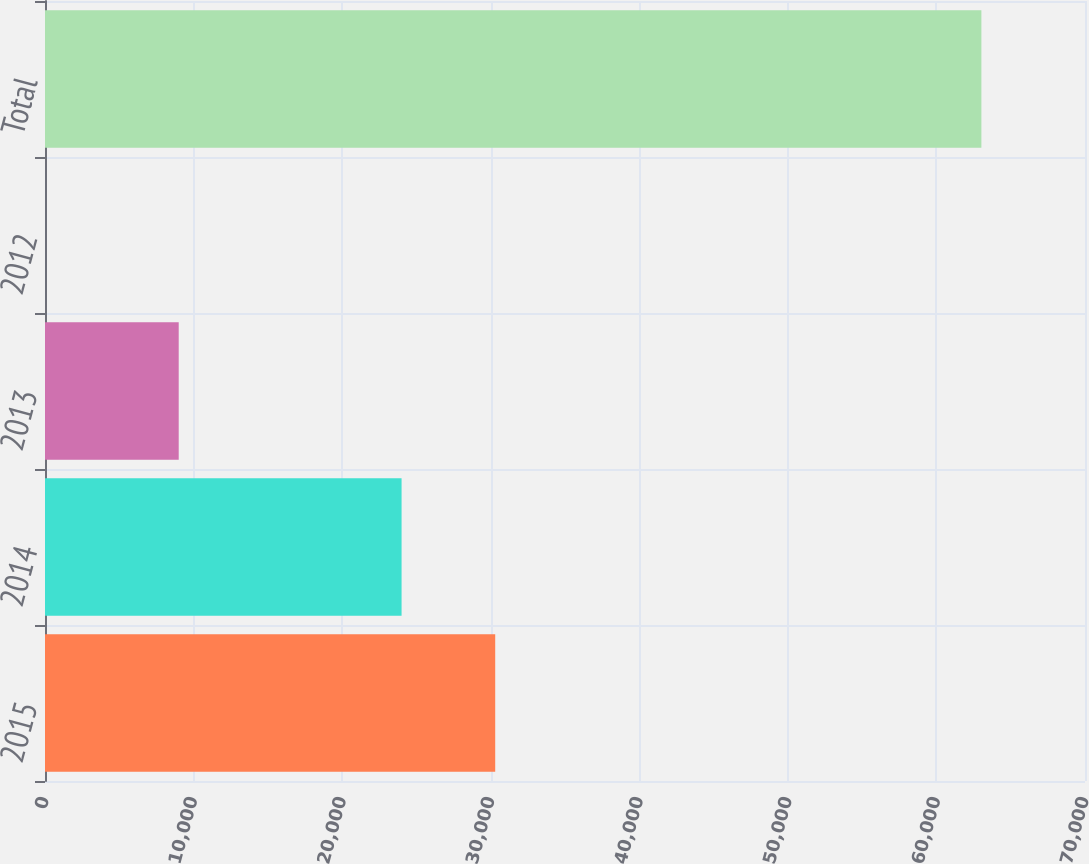<chart> <loc_0><loc_0><loc_500><loc_500><bar_chart><fcel>2015<fcel>2014<fcel>2013<fcel>2012<fcel>Total<nl><fcel>30302.5<fcel>24000<fcel>9000<fcel>1.37<fcel>63026<nl></chart> 